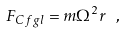Convert formula to latex. <formula><loc_0><loc_0><loc_500><loc_500>F _ { C f g l } = m { \Omega } ^ { 2 } r \ ,</formula> 